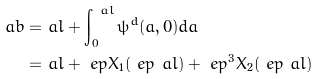<formula> <loc_0><loc_0><loc_500><loc_500>\ a b = & \ a l + \int _ { 0 } ^ { \ a l } \psi ^ { d } ( a , 0 ) d a \\ = & \ a l + \ e p X _ { 1 } ( \ e p \ a l ) + \ e p ^ { 3 } X _ { 2 } ( \ e p \ a l )</formula> 